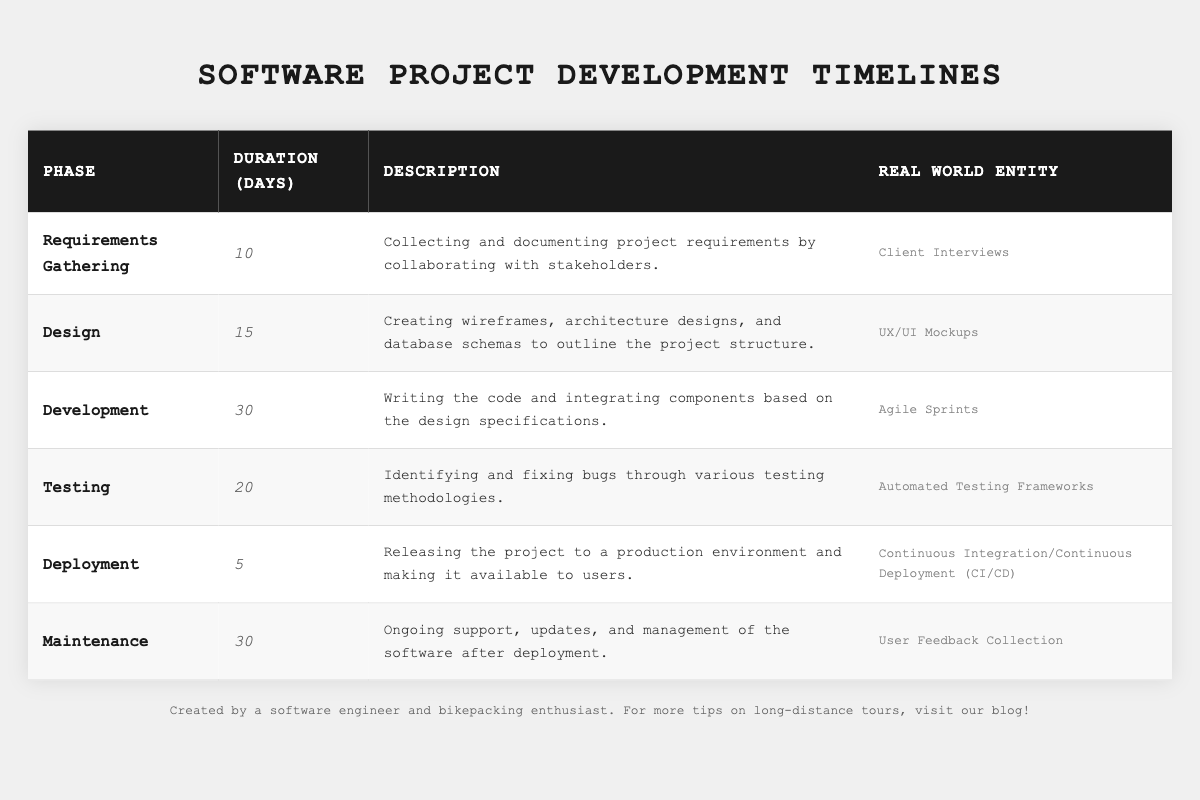What is the total duration of all phases combined? To find the total duration, we sum the duration of all phases: 10 (Requirements Gathering) + 15 (Design) + 30 (Development) + 20 (Testing) + 5 (Deployment) + 30 (Maintenance) = 110 days.
Answer: 110 days How many days does the Testing phase take? The Testing phase's duration is clearly listed in the table as 20 days.
Answer: 20 days Is the Design phase longer than the Deployment phase? The Design phase lasts 15 days, while the Deployment phase lasts 5 days. Since 15 is greater than 5, the statement is true.
Answer: Yes What is the average duration of all phases? To calculate the average, we first sum the durations (10 + 15 + 30 + 20 + 5 + 30 = 110 days) and divide by the number of phases (6): 110 / 6 = 18.33 days.
Answer: 18.33 days Which phase has the shortest duration, and how many days does it take? By examining the durations, the Deployment phase has the shortest duration of 5 days.
Answer: Deployment phase, 5 days Is the duration of the Development phase more than the sum of durations of Requirements Gathering and Deployment phases? The Development phase is 30 days, Requirements Gathering is 10 days, and Deployment is 5 days, so the sum of the two is 10 + 5 = 15 days. Since 30 is greater than 15, the answer is yes.
Answer: Yes What phases take more than 25 days? The phases that take more than 25 days are Development (30 days) and Maintenance (30 days).
Answer: Development and Maintenance Calculate the total duration of phases before deployment. The phases before Deployment are Requirements Gathering (10), Design (15), Development (30), and Testing (20). Adding these gives 10 + 15 + 30 + 20 = 75 days before deployment.
Answer: 75 days What is the duration difference between the longest and shortest phases? The longest phase is Development (30 days) and the shortest is Deployment (5 days). The difference is 30 - 5 = 25 days.
Answer: 25 days Which phase involves user feedback collection? The phase that involves user feedback collection is the Maintenance phase.
Answer: Maintenance phase 